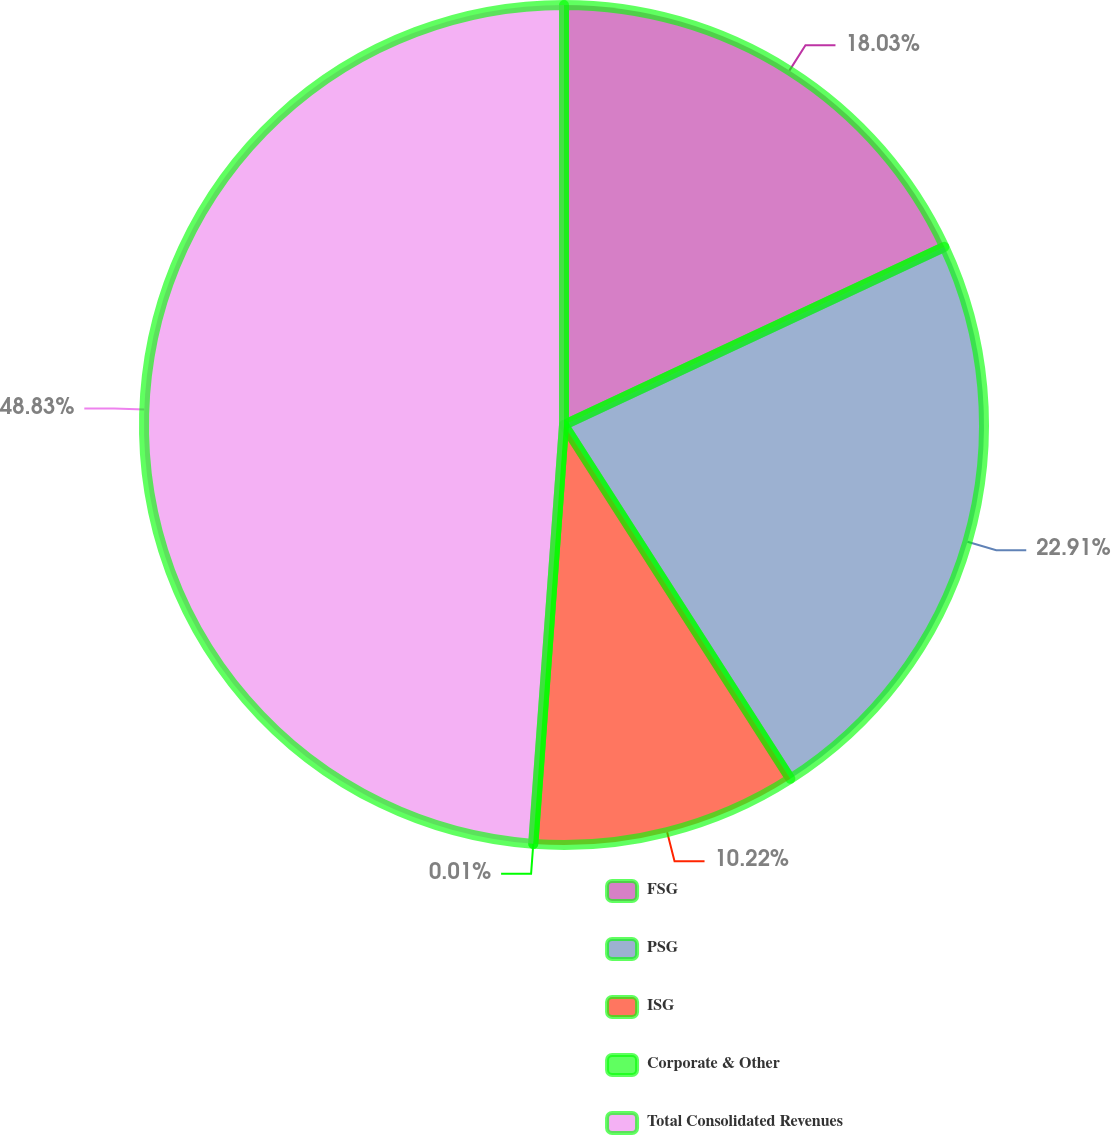Convert chart. <chart><loc_0><loc_0><loc_500><loc_500><pie_chart><fcel>FSG<fcel>PSG<fcel>ISG<fcel>Corporate & Other<fcel>Total Consolidated Revenues<nl><fcel>18.03%<fcel>22.91%<fcel>10.22%<fcel>0.01%<fcel>48.83%<nl></chart> 